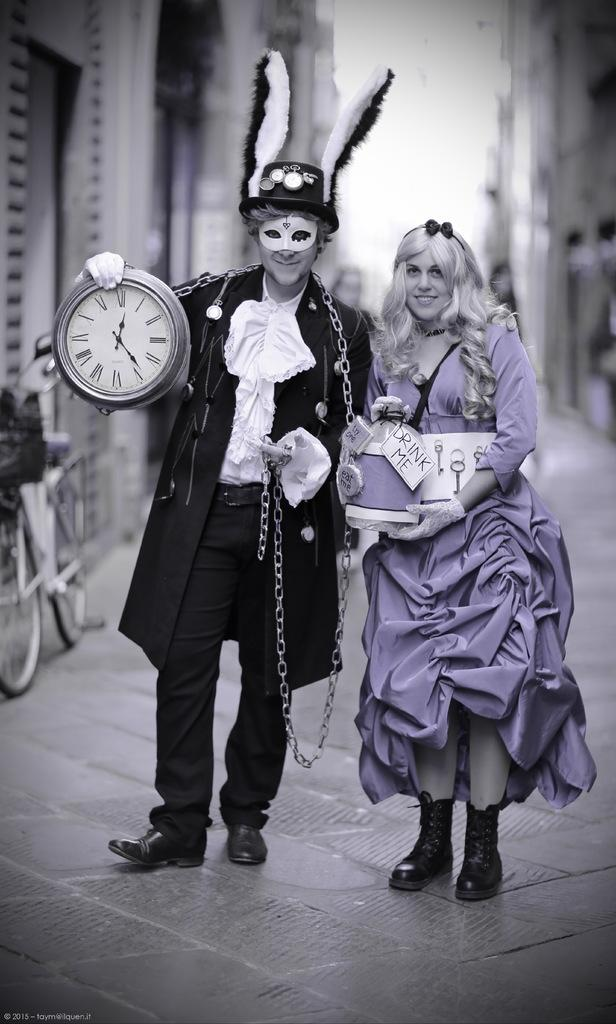<image>
Share a concise interpretation of the image provided. A woman dressed like Alice has a bottle that says "drink me" on it. 